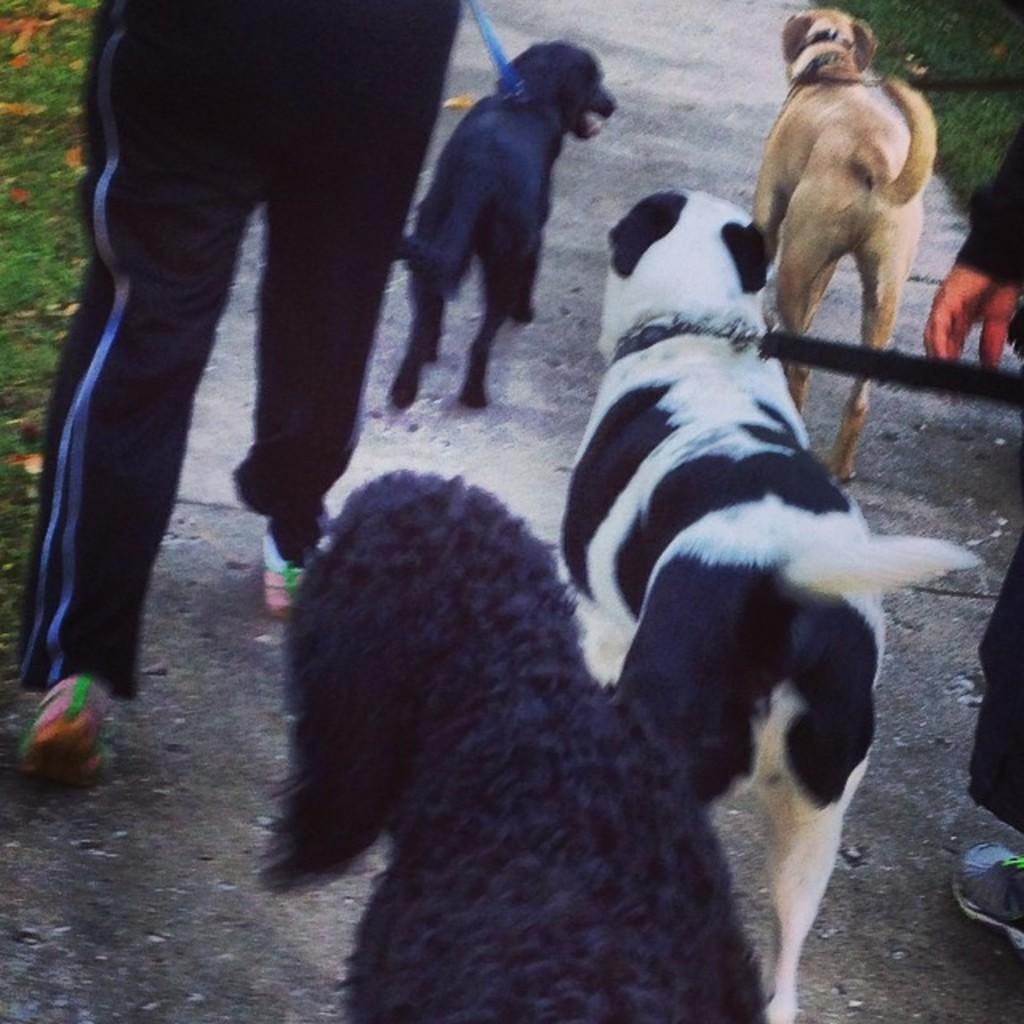What type of animals can be seen in the image? There are dogs in the image. Who else is present in the image besides the dogs? There is a group of people in the image. What type of terrain is visible on the left side of the image? Grass is present on the left side of the image. What type of terrain is visible on the right side of the image? Grass is present on the right side of the image. What type of art can be seen hanging on the wall in the image? There is no mention of any art or wall in the provided facts, so we cannot answer this question based on the information given. 